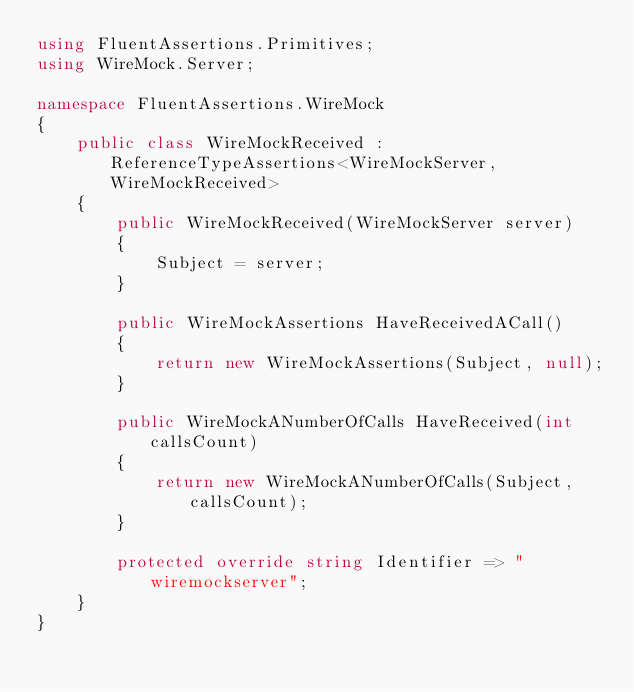Convert code to text. <code><loc_0><loc_0><loc_500><loc_500><_C#_>using FluentAssertions.Primitives;
using WireMock.Server;

namespace FluentAssertions.WireMock
{
    public class WireMockReceived : ReferenceTypeAssertions<WireMockServer, WireMockReceived>
    {
        public WireMockReceived(WireMockServer server)
        {
            Subject = server;
        }
        
        public WireMockAssertions HaveReceivedACall()
        {
            return new WireMockAssertions(Subject, null);
        }
        
        public WireMockANumberOfCalls HaveReceived(int callsCount)
        {
            return new WireMockANumberOfCalls(Subject, callsCount);
        }

        protected override string Identifier => "wiremockserver";
    }
}</code> 